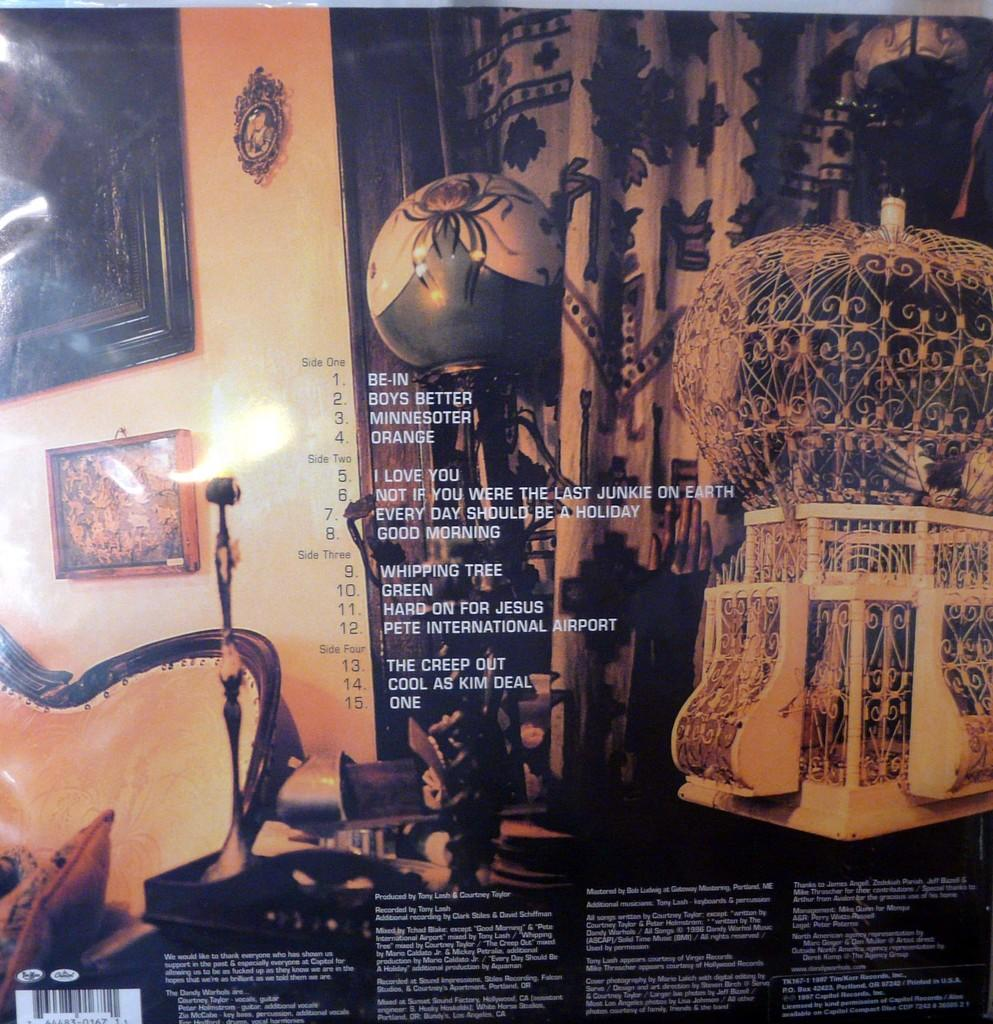Provide a one-sentence caption for the provided image. The back of an album cover with the first song called Be-In. 